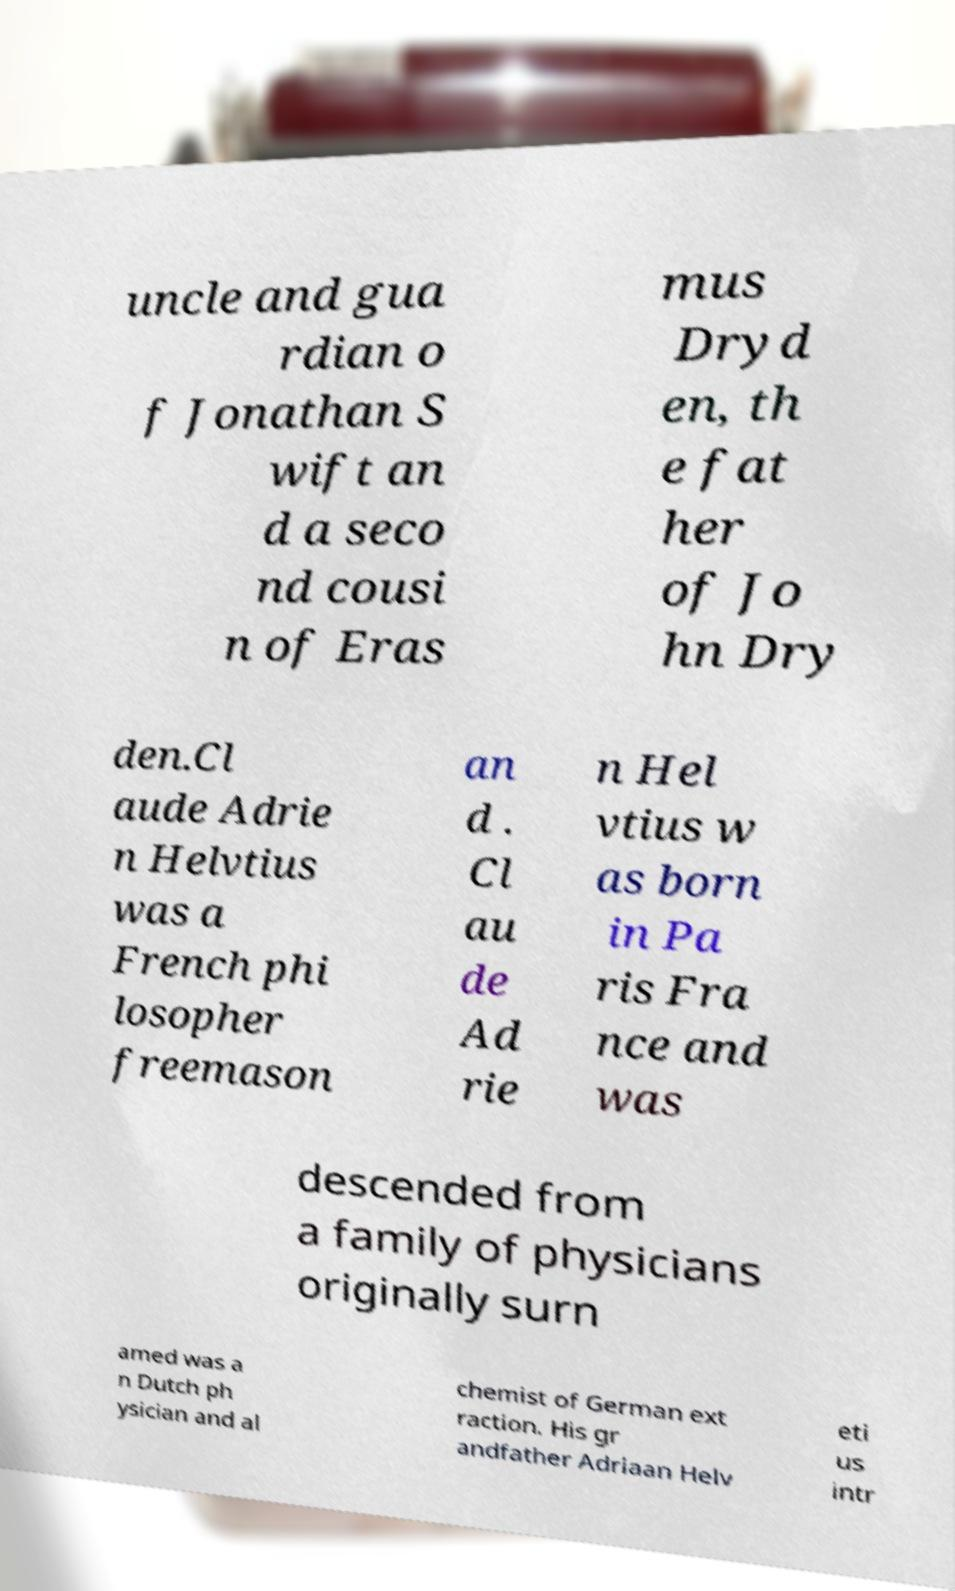I need the written content from this picture converted into text. Can you do that? uncle and gua rdian o f Jonathan S wift an d a seco nd cousi n of Eras mus Dryd en, th e fat her of Jo hn Dry den.Cl aude Adrie n Helvtius was a French phi losopher freemason an d . Cl au de Ad rie n Hel vtius w as born in Pa ris Fra nce and was descended from a family of physicians originally surn amed was a n Dutch ph ysician and al chemist of German ext raction. His gr andfather Adriaan Helv eti us intr 